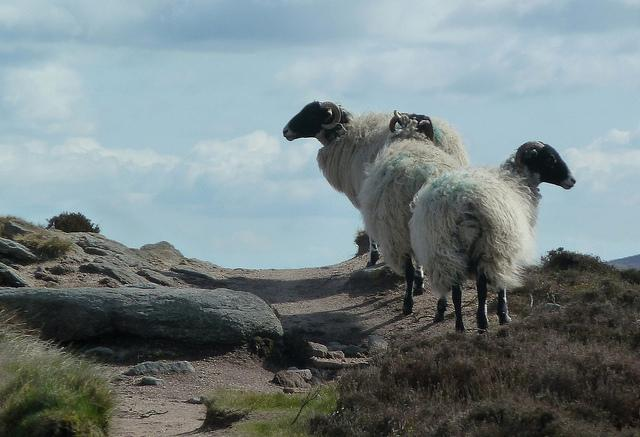What is a process that is related to these animals? Please explain your reasoning. shearing. Sheep get sheared for their wool when it gets very long. 